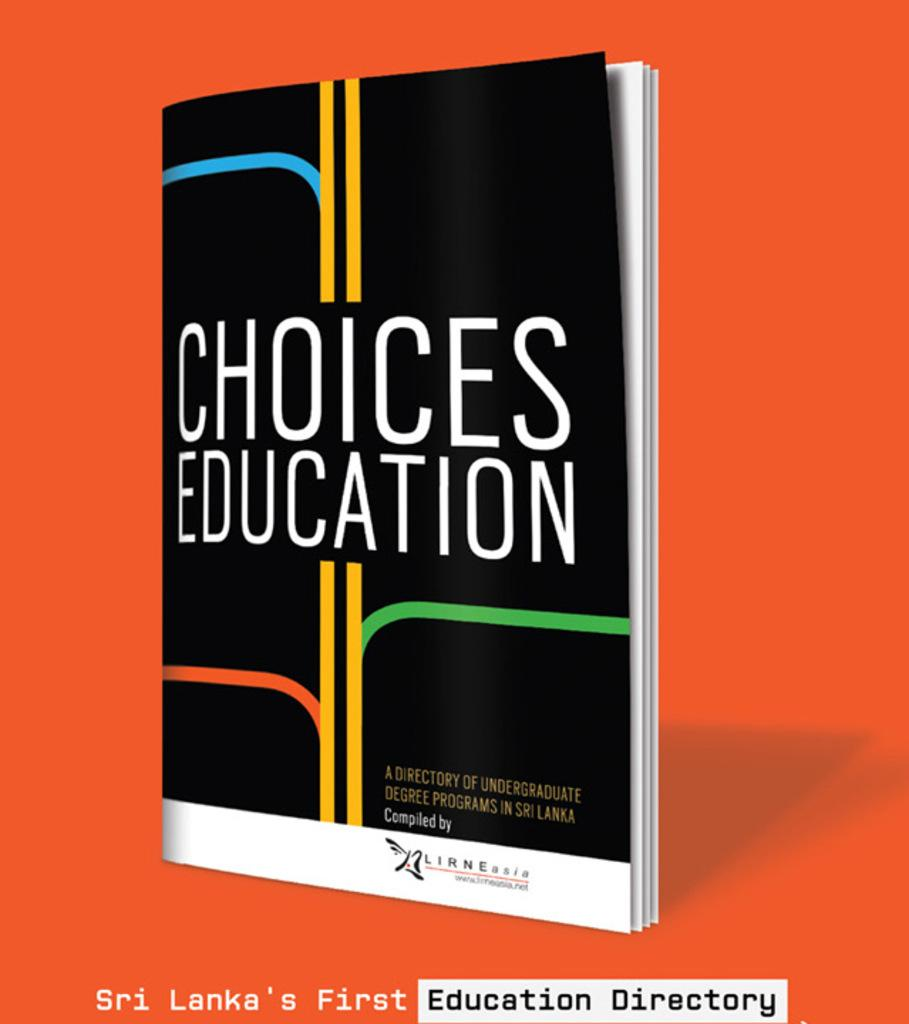<image>
Give a short and clear explanation of the subsequent image. The cover of the book Choices Education, which is Shi Lanka's First Education Directory 